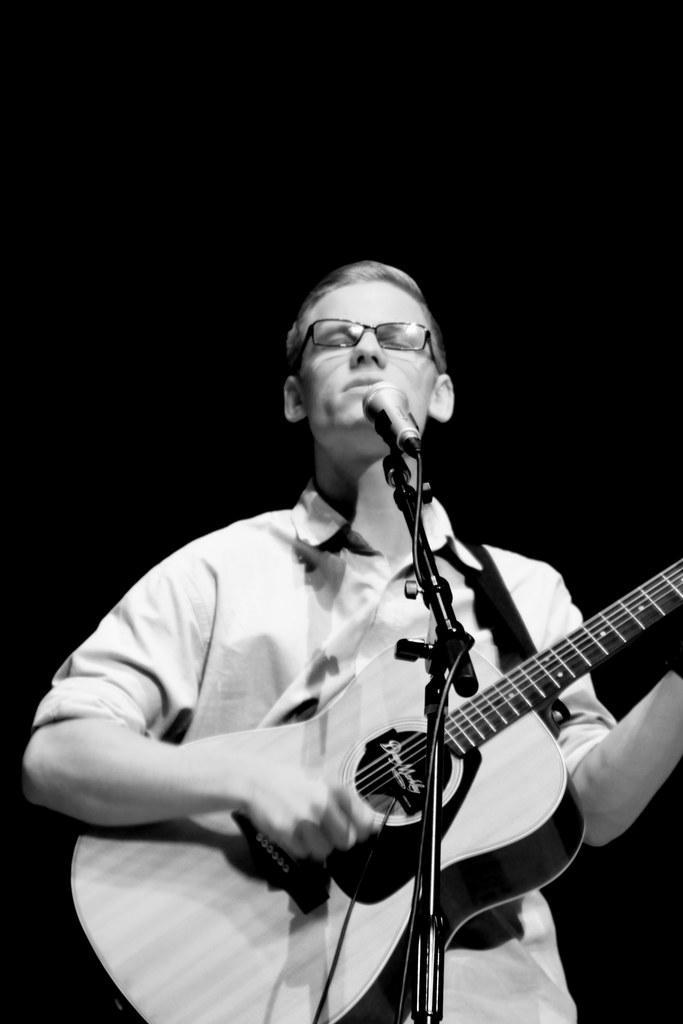Could you give a brief overview of what you see in this image? As we see in the image, there is a person playing a guitar and he is standing in front of a mic. 